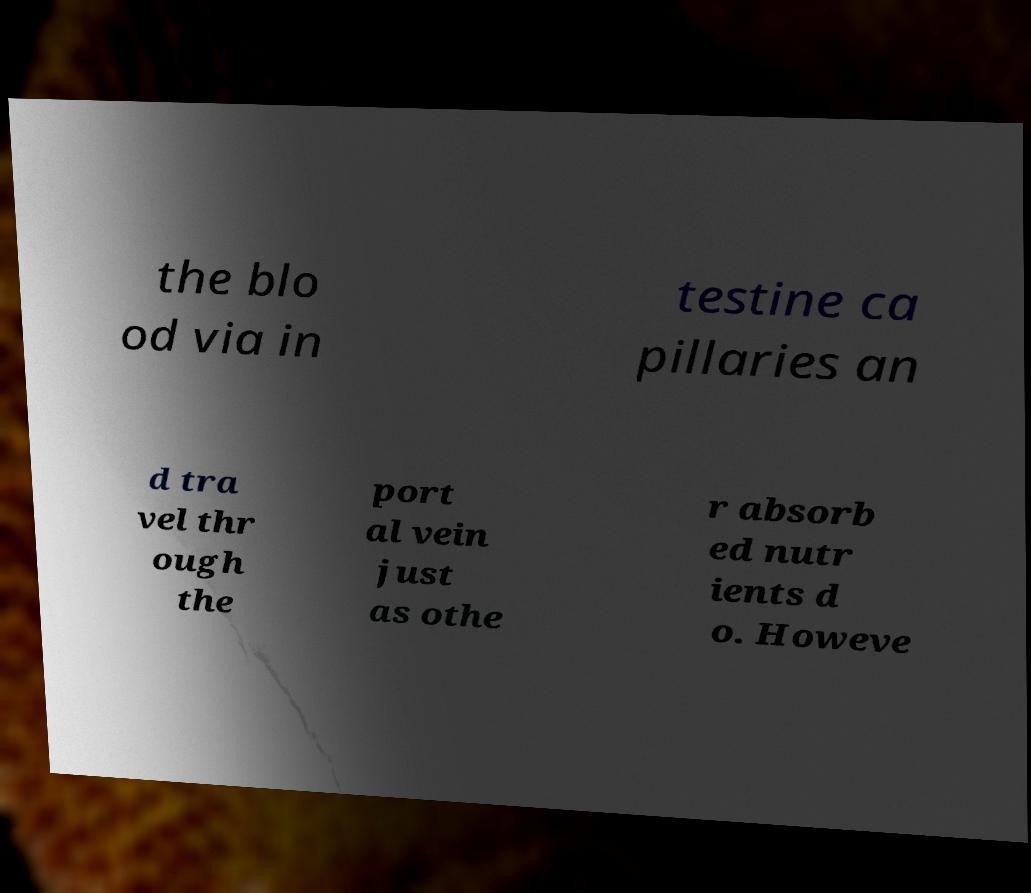Can you read and provide the text displayed in the image?This photo seems to have some interesting text. Can you extract and type it out for me? the blo od via in testine ca pillaries an d tra vel thr ough the port al vein just as othe r absorb ed nutr ients d o. Howeve 